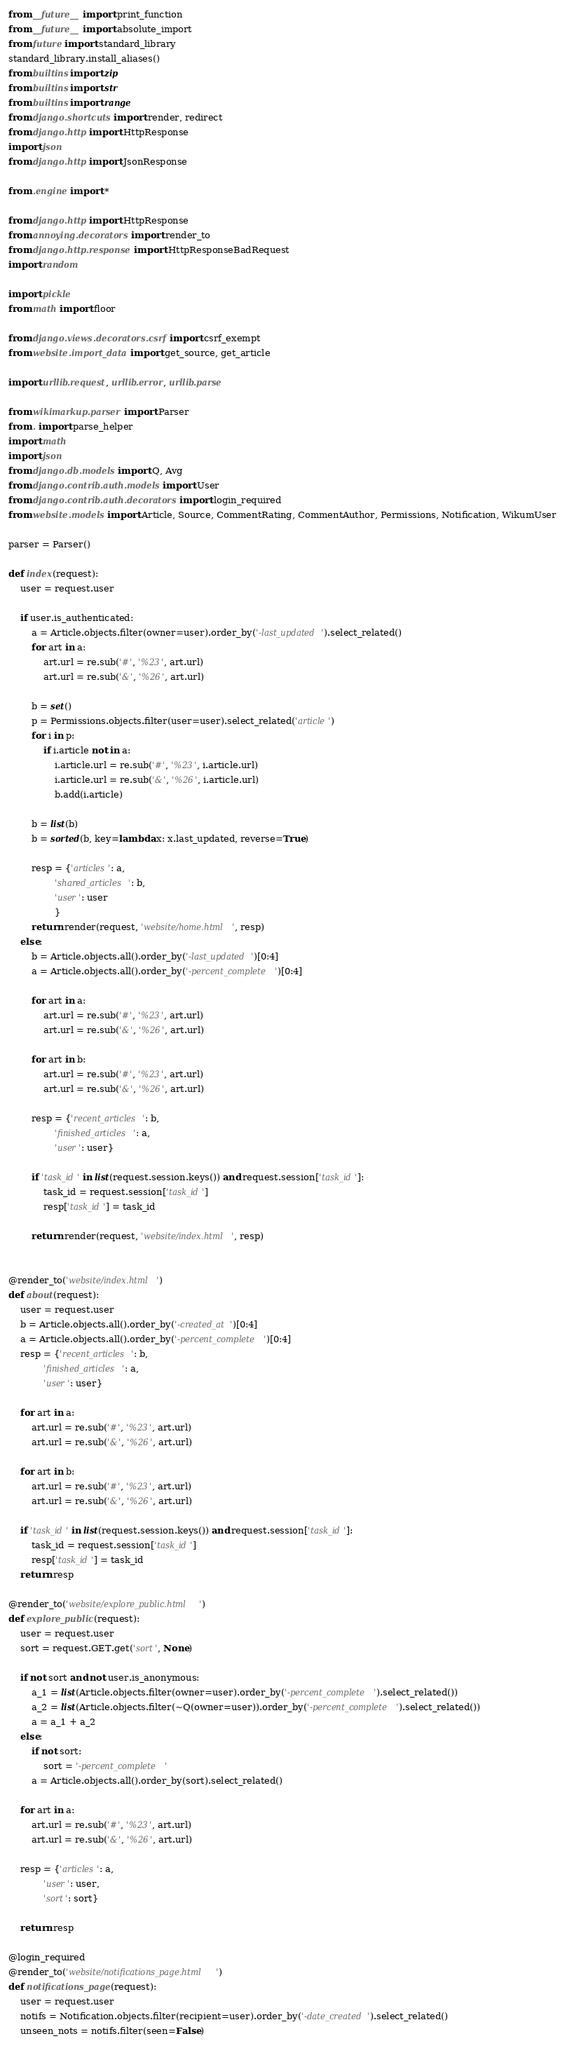Convert code to text. <code><loc_0><loc_0><loc_500><loc_500><_Python_>from __future__ import print_function
from __future__ import absolute_import
from future import standard_library
standard_library.install_aliases()
from builtins import zip
from builtins import str
from builtins import range
from django.shortcuts import render, redirect
from django.http import HttpResponse
import json
from django.http import JsonResponse

from .engine import *

from django.http import HttpResponse
from annoying.decorators import render_to
from django.http.response import HttpResponseBadRequest
import random

import pickle
from math import floor

from django.views.decorators.csrf import csrf_exempt
from website.import_data import get_source, get_article

import urllib.request, urllib.error, urllib.parse

from wikimarkup.parser import Parser
from . import parse_helper
import math
import json
from django.db.models import Q, Avg
from django.contrib.auth.models import User
from django.contrib.auth.decorators import login_required
from website.models import Article, Source, CommentRating, CommentAuthor, Permissions, Notification, WikumUser

parser = Parser()

def index(request):
    user = request.user

    if user.is_authenticated:
        a = Article.objects.filter(owner=user).order_by('-last_updated').select_related()
        for art in a:
            art.url = re.sub('#', '%23', art.url)
            art.url = re.sub('&', '%26', art.url)
            
        b = set()
        p = Permissions.objects.filter(user=user).select_related('article')
        for i in p:
            if i.article not in a:
                i.article.url = re.sub('#', '%23', i.article.url)
                i.article.url = re.sub('&', '%26', i.article.url)
                b.add(i.article)
        
        b = list(b)
        b = sorted(b, key=lambda x: x.last_updated, reverse=True)
        
        resp = {'articles': a,
                'shared_articles': b,
                'user': user
                }
        return render(request, 'website/home.html', resp)
    else:
        b = Article.objects.all().order_by('-last_updated')[0:4]
        a = Article.objects.all().order_by('-percent_complete')[0:4]
        
        for art in a:
            art.url = re.sub('#', '%23', art.url)
            art.url = re.sub('&', '%26', art.url)
            
        for art in b:
            art.url = re.sub('#', '%23', art.url)
            art.url = re.sub('&', '%26', art.url)
        
        resp = {'recent_articles': b,
                'finished_articles': a,
                'user': user}
        
        if 'task_id' in list(request.session.keys()) and request.session['task_id']:
            task_id = request.session['task_id']
            resp['task_id'] = task_id

        return render(request, 'website/index.html', resp)


@render_to('website/index.html')
def about(request):
    user = request.user
    b = Article.objects.all().order_by('-created_at')[0:4]
    a = Article.objects.all().order_by('-percent_complete')[0:4]
    resp = {'recent_articles': b,
            'finished_articles': a,
            'user': user}
    
    for art in a:
        art.url = re.sub('#', '%23', art.url)
        art.url = re.sub('&', '%26', art.url)
        
    for art in b:
        art.url = re.sub('#', '%23', art.url)
        art.url = re.sub('&', '%26', art.url)
    
    if 'task_id' in list(request.session.keys()) and request.session['task_id']:
        task_id = request.session['task_id']
        resp['task_id'] = task_id
    return resp

@render_to('website/explore_public.html')
def explore_public(request):
    user = request.user
    sort = request.GET.get('sort', None)
    
    if not sort and not user.is_anonymous:
        a_1 = list(Article.objects.filter(owner=user).order_by('-percent_complete').select_related())
        a_2 = list(Article.objects.filter(~Q(owner=user)).order_by('-percent_complete').select_related())
        a = a_1 + a_2
    else:
        if not sort:
            sort = '-percent_complete'
        a = Article.objects.all().order_by(sort).select_related()
    
    for art in a:
        art.url = re.sub('#', '%23', art.url)
        art.url = re.sub('&', '%26', art.url)

    resp = {'articles': a,
            'user': user,
            'sort': sort}

    return resp

@login_required
@render_to('website/notifications_page.html')
def notifications_page(request):
    user = request.user
    notifs = Notification.objects.filter(recipient=user).order_by('-date_created').select_related()
    unseen_nots = notifs.filter(seen=False)</code> 